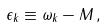Convert formula to latex. <formula><loc_0><loc_0><loc_500><loc_500>\epsilon _ { k } \equiv \omega _ { k } - M \, ,</formula> 